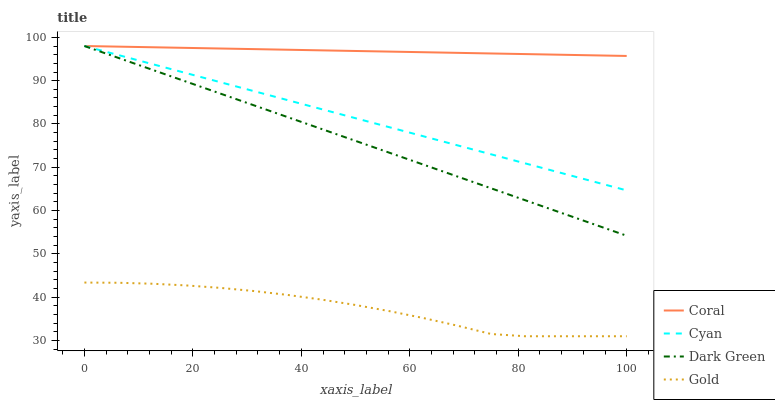Does Gold have the minimum area under the curve?
Answer yes or no. Yes. Does Coral have the maximum area under the curve?
Answer yes or no. Yes. Does Coral have the minimum area under the curve?
Answer yes or no. No. Does Gold have the maximum area under the curve?
Answer yes or no. No. Is Coral the smoothest?
Answer yes or no. Yes. Is Gold the roughest?
Answer yes or no. Yes. Is Gold the smoothest?
Answer yes or no. No. Is Coral the roughest?
Answer yes or no. No. Does Coral have the lowest value?
Answer yes or no. No. Does Dark Green have the highest value?
Answer yes or no. Yes. Does Gold have the highest value?
Answer yes or no. No. Is Gold less than Cyan?
Answer yes or no. Yes. Is Dark Green greater than Gold?
Answer yes or no. Yes. Does Coral intersect Dark Green?
Answer yes or no. Yes. Is Coral less than Dark Green?
Answer yes or no. No. Is Coral greater than Dark Green?
Answer yes or no. No. Does Gold intersect Cyan?
Answer yes or no. No. 